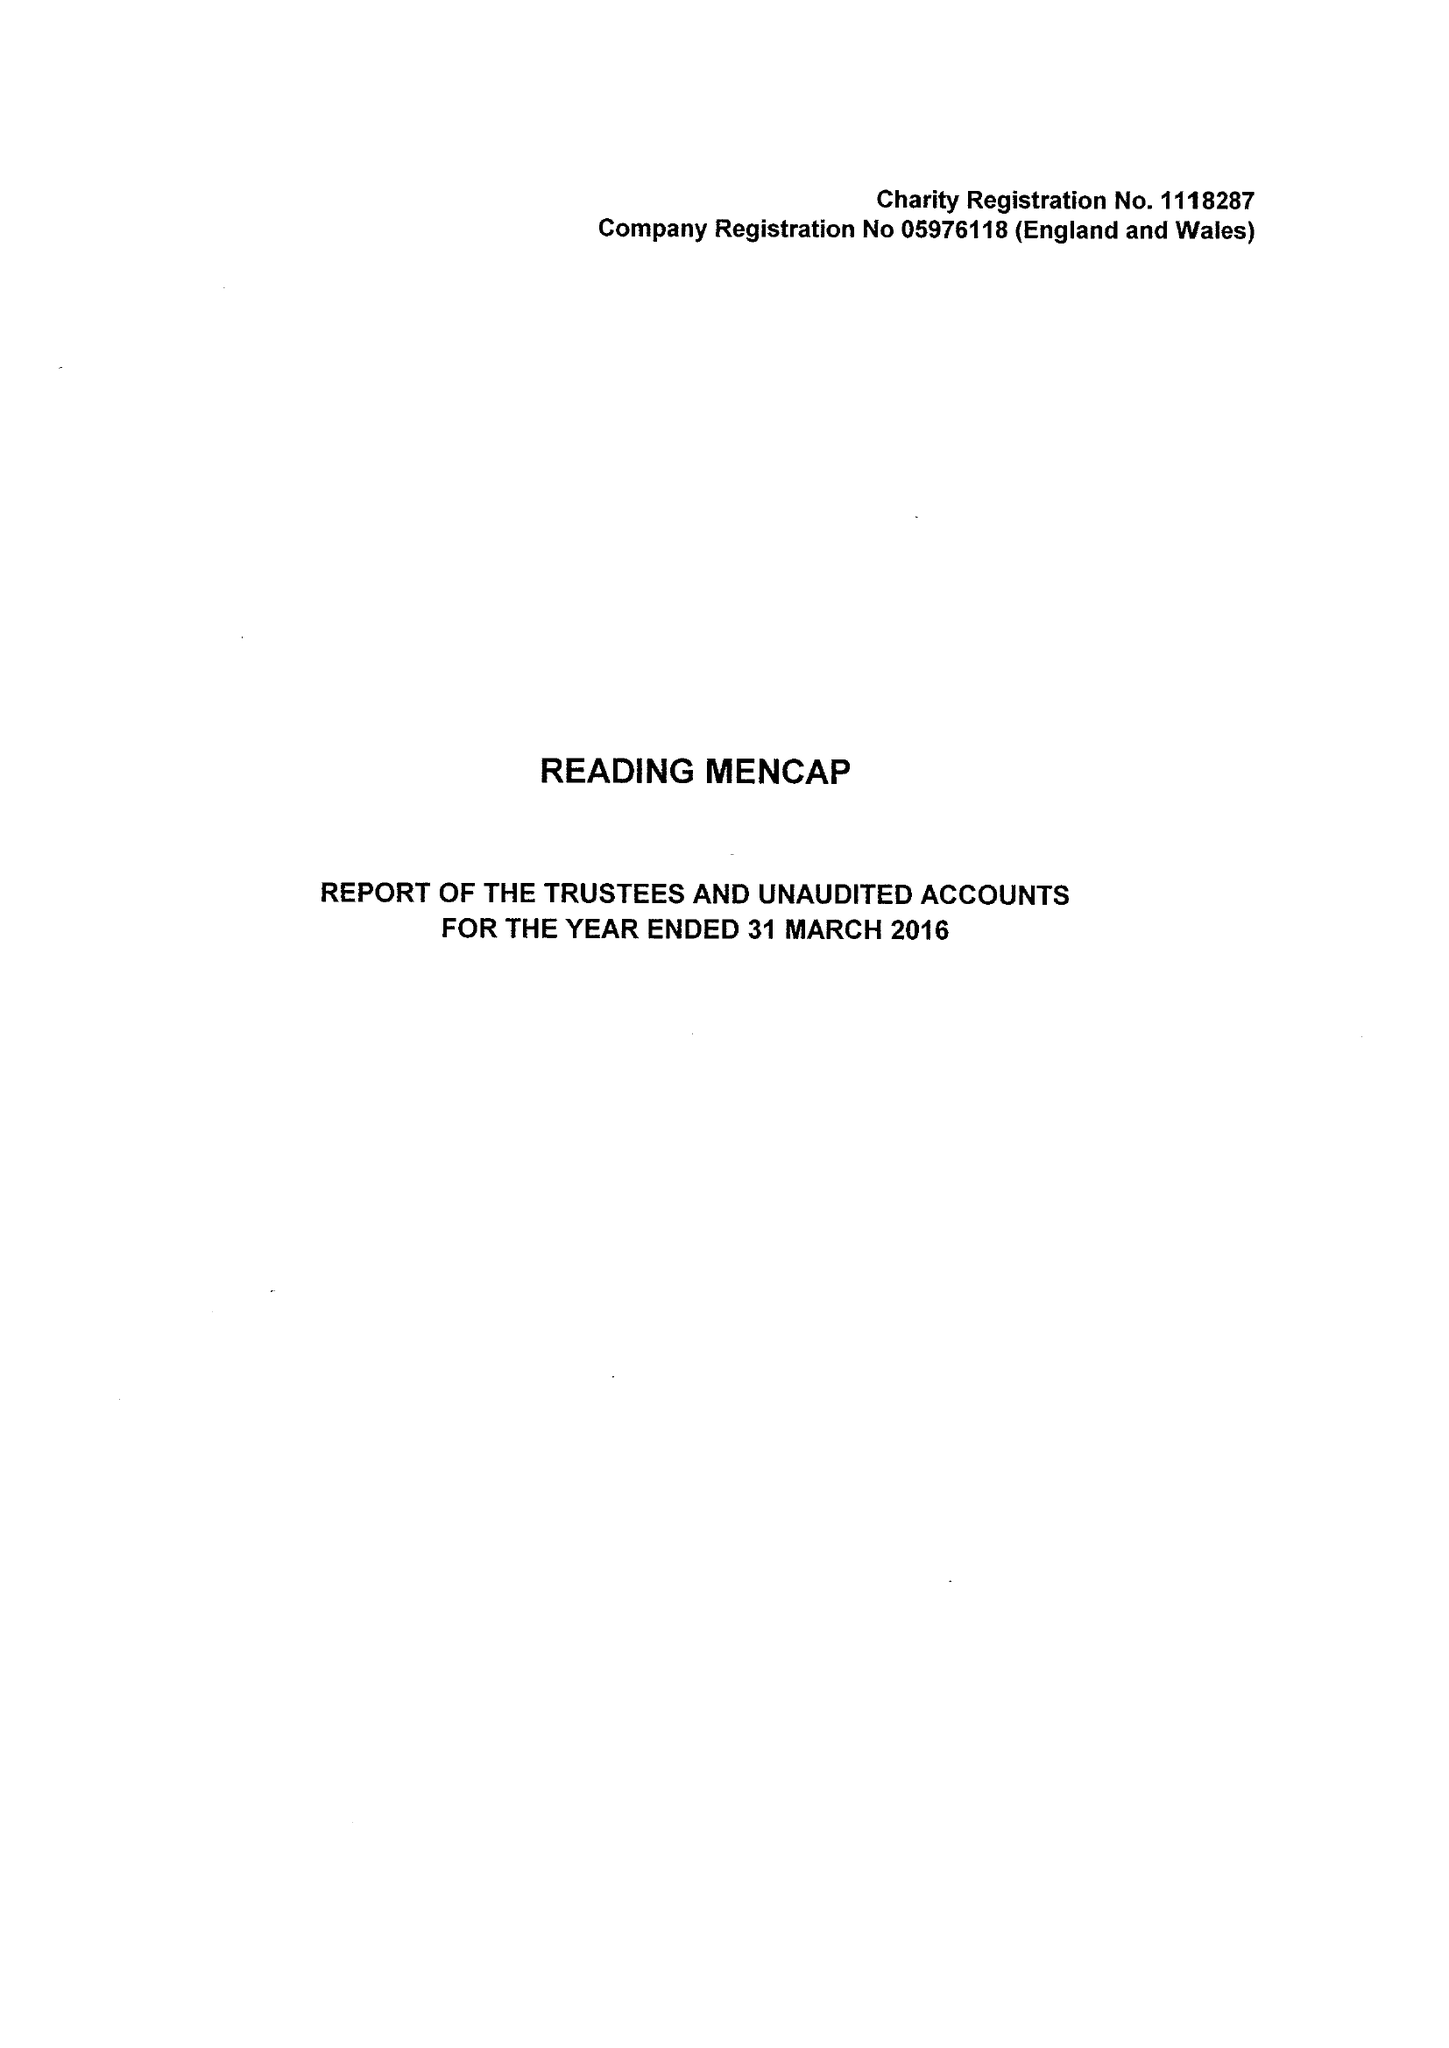What is the value for the charity_number?
Answer the question using a single word or phrase. 1118287 